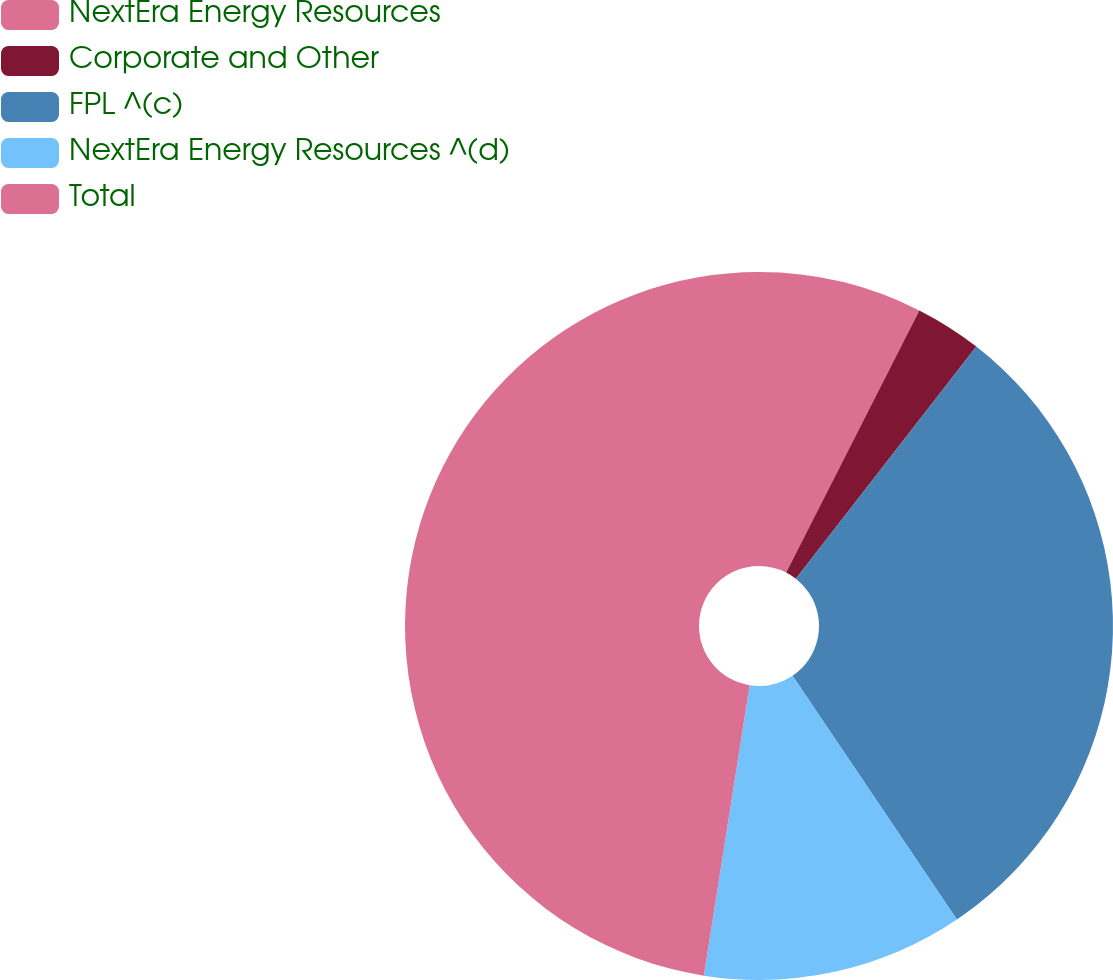<chart> <loc_0><loc_0><loc_500><loc_500><pie_chart><fcel>NextEra Energy Resources<fcel>Corporate and Other<fcel>FPL ^(c)<fcel>NextEra Energy Resources ^(d)<fcel>Total<nl><fcel>7.48%<fcel>3.04%<fcel>30.04%<fcel>11.93%<fcel>47.51%<nl></chart> 